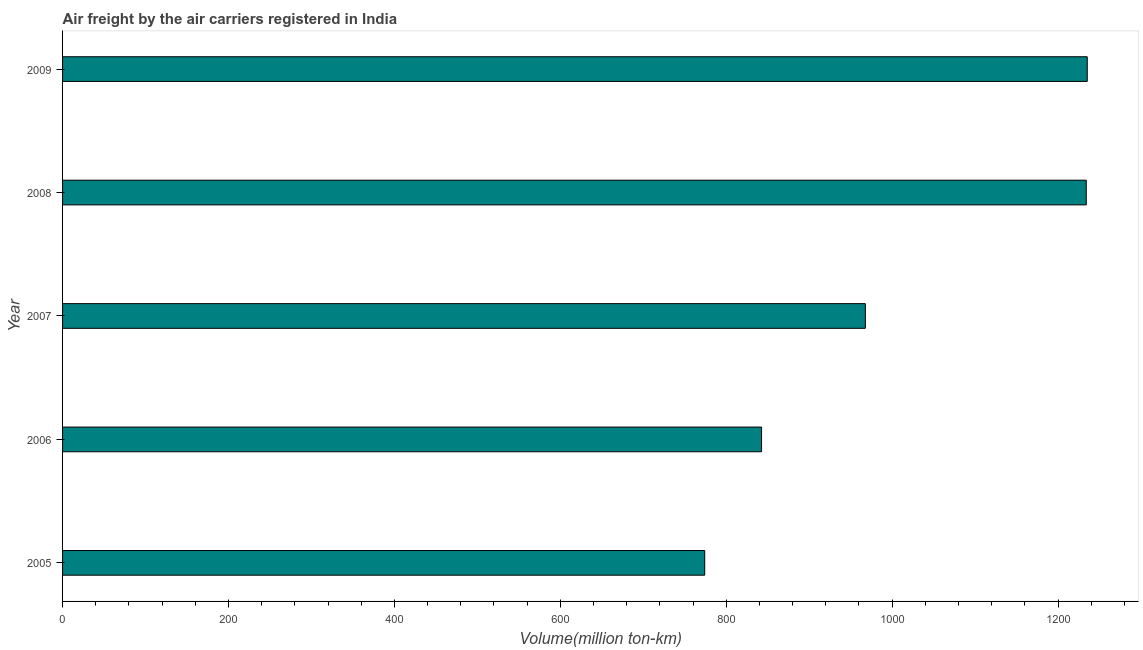Does the graph contain any zero values?
Give a very brief answer. No. Does the graph contain grids?
Your answer should be very brief. No. What is the title of the graph?
Your answer should be compact. Air freight by the air carriers registered in India. What is the label or title of the X-axis?
Make the answer very short. Volume(million ton-km). What is the label or title of the Y-axis?
Your answer should be compact. Year. What is the air freight in 2006?
Provide a succinct answer. 842.55. Across all years, what is the maximum air freight?
Offer a very short reply. 1235.16. Across all years, what is the minimum air freight?
Keep it short and to the point. 774.04. In which year was the air freight maximum?
Offer a very short reply. 2009. In which year was the air freight minimum?
Ensure brevity in your answer.  2005. What is the sum of the air freight?
Give a very brief answer. 5053.37. What is the difference between the air freight in 2006 and 2008?
Ensure brevity in your answer.  -391.39. What is the average air freight per year?
Offer a terse response. 1010.67. What is the median air freight?
Your response must be concise. 967.68. In how many years, is the air freight greater than 120 million ton-km?
Offer a terse response. 5. What is the ratio of the air freight in 2005 to that in 2009?
Your response must be concise. 0.63. Is the difference between the air freight in 2005 and 2008 greater than the difference between any two years?
Your answer should be compact. No. What is the difference between the highest and the second highest air freight?
Your answer should be compact. 1.22. What is the difference between the highest and the lowest air freight?
Ensure brevity in your answer.  461.12. How many bars are there?
Your answer should be very brief. 5. Are all the bars in the graph horizontal?
Make the answer very short. Yes. What is the difference between two consecutive major ticks on the X-axis?
Offer a very short reply. 200. What is the Volume(million ton-km) of 2005?
Give a very brief answer. 774.04. What is the Volume(million ton-km) in 2006?
Give a very brief answer. 842.55. What is the Volume(million ton-km) in 2007?
Make the answer very short. 967.68. What is the Volume(million ton-km) of 2008?
Provide a short and direct response. 1233.94. What is the Volume(million ton-km) in 2009?
Provide a succinct answer. 1235.16. What is the difference between the Volume(million ton-km) in 2005 and 2006?
Offer a very short reply. -68.51. What is the difference between the Volume(million ton-km) in 2005 and 2007?
Provide a succinct answer. -193.64. What is the difference between the Volume(million ton-km) in 2005 and 2008?
Make the answer very short. -459.9. What is the difference between the Volume(million ton-km) in 2005 and 2009?
Provide a succinct answer. -461.12. What is the difference between the Volume(million ton-km) in 2006 and 2007?
Your answer should be compact. -125.13. What is the difference between the Volume(million ton-km) in 2006 and 2008?
Your answer should be very brief. -391.39. What is the difference between the Volume(million ton-km) in 2006 and 2009?
Offer a terse response. -392.61. What is the difference between the Volume(million ton-km) in 2007 and 2008?
Your answer should be compact. -266.25. What is the difference between the Volume(million ton-km) in 2007 and 2009?
Make the answer very short. -267.47. What is the difference between the Volume(million ton-km) in 2008 and 2009?
Make the answer very short. -1.22. What is the ratio of the Volume(million ton-km) in 2005 to that in 2006?
Offer a terse response. 0.92. What is the ratio of the Volume(million ton-km) in 2005 to that in 2008?
Offer a terse response. 0.63. What is the ratio of the Volume(million ton-km) in 2005 to that in 2009?
Your response must be concise. 0.63. What is the ratio of the Volume(million ton-km) in 2006 to that in 2007?
Ensure brevity in your answer.  0.87. What is the ratio of the Volume(million ton-km) in 2006 to that in 2008?
Offer a very short reply. 0.68. What is the ratio of the Volume(million ton-km) in 2006 to that in 2009?
Your answer should be very brief. 0.68. What is the ratio of the Volume(million ton-km) in 2007 to that in 2008?
Your answer should be very brief. 0.78. What is the ratio of the Volume(million ton-km) in 2007 to that in 2009?
Make the answer very short. 0.78. What is the ratio of the Volume(million ton-km) in 2008 to that in 2009?
Offer a very short reply. 1. 